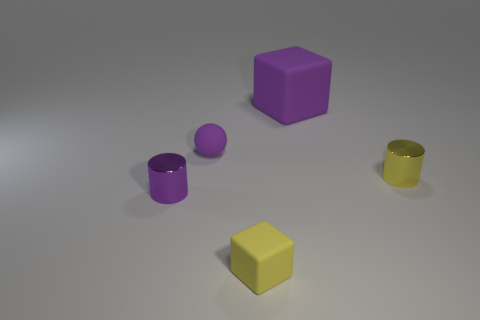What number of tiny cylinders are the same color as the small rubber block? 1 